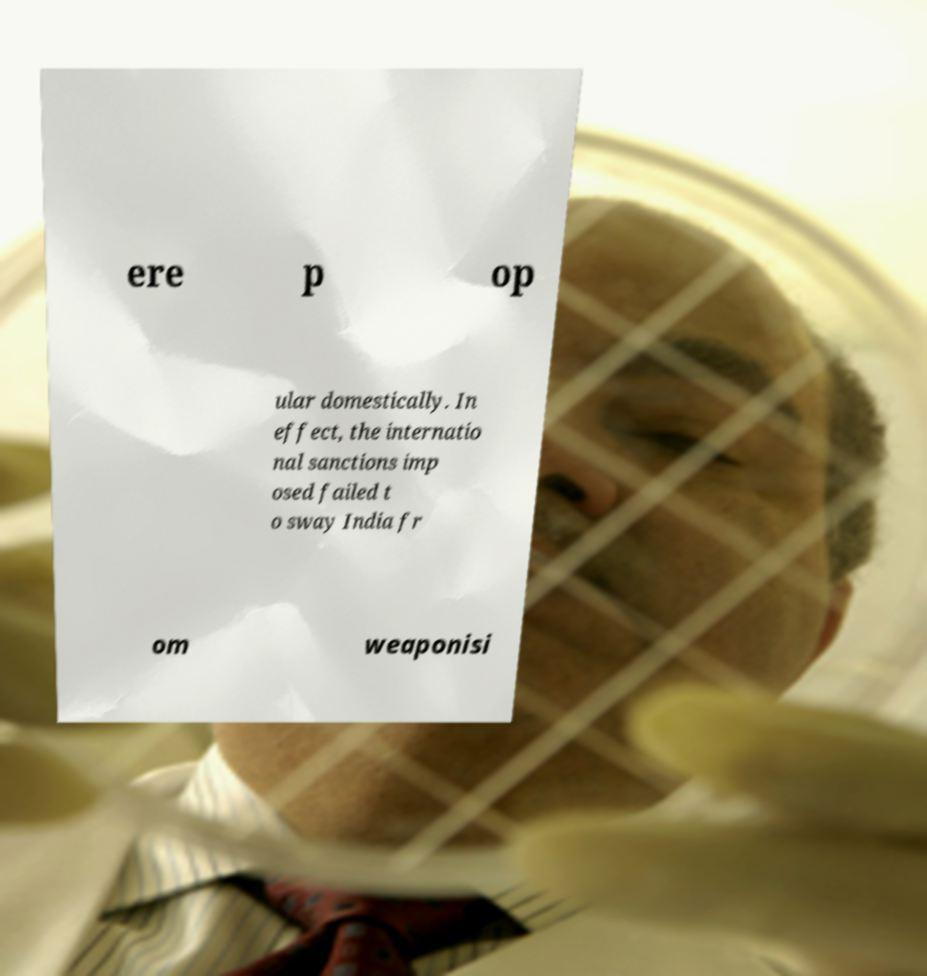Please read and relay the text visible in this image. What does it say? ere p op ular domestically. In effect, the internatio nal sanctions imp osed failed t o sway India fr om weaponisi 